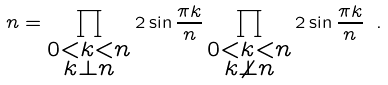Convert formula to latex. <formula><loc_0><loc_0><loc_500><loc_500>n = \prod _ { \substack { 0 < k < n \\ k \perp n } } 2 \sin \frac { \pi k } { n } \prod _ { \substack { 0 < k < n \\ k \not { \perp } n } } 2 \sin \frac { \pi k } { n } \ .</formula> 